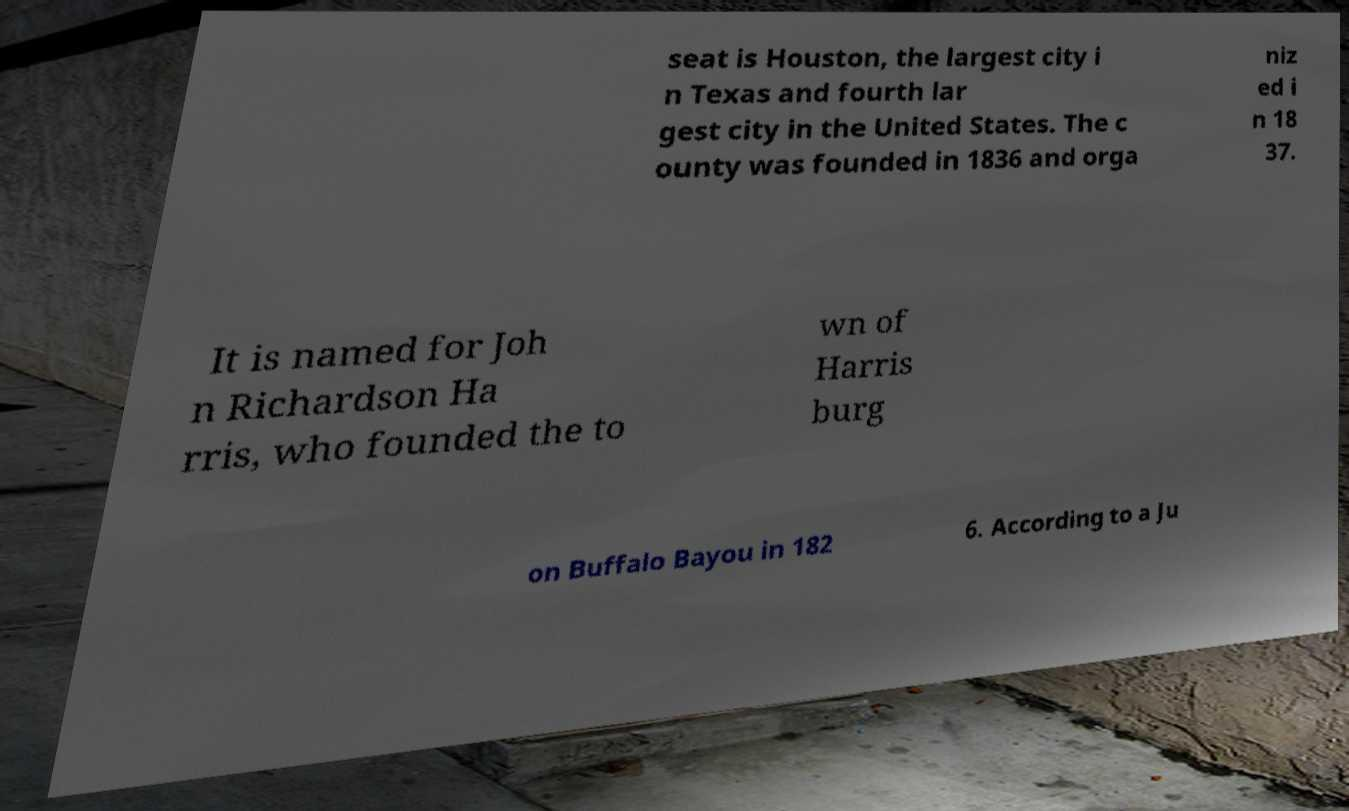There's text embedded in this image that I need extracted. Can you transcribe it verbatim? seat is Houston, the largest city i n Texas and fourth lar gest city in the United States. The c ounty was founded in 1836 and orga niz ed i n 18 37. It is named for Joh n Richardson Ha rris, who founded the to wn of Harris burg on Buffalo Bayou in 182 6. According to a Ju 